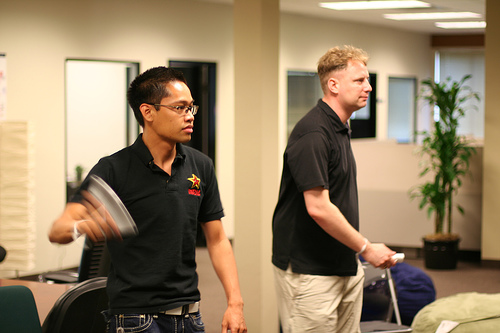Describe the mood of the setting in the image. The setting has a relaxed and engaging atmosphere, likely a casual office or gaming session among colleagues. 